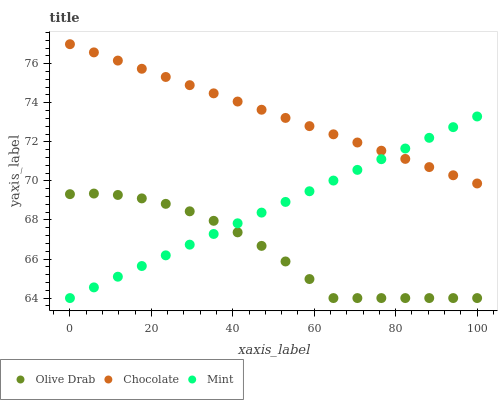Does Olive Drab have the minimum area under the curve?
Answer yes or no. Yes. Does Chocolate have the maximum area under the curve?
Answer yes or no. Yes. Does Chocolate have the minimum area under the curve?
Answer yes or no. No. Does Olive Drab have the maximum area under the curve?
Answer yes or no. No. Is Mint the smoothest?
Answer yes or no. Yes. Is Olive Drab the roughest?
Answer yes or no. Yes. Is Chocolate the smoothest?
Answer yes or no. No. Is Chocolate the roughest?
Answer yes or no. No. Does Mint have the lowest value?
Answer yes or no. Yes. Does Chocolate have the lowest value?
Answer yes or no. No. Does Chocolate have the highest value?
Answer yes or no. Yes. Does Olive Drab have the highest value?
Answer yes or no. No. Is Olive Drab less than Chocolate?
Answer yes or no. Yes. Is Chocolate greater than Olive Drab?
Answer yes or no. Yes. Does Olive Drab intersect Mint?
Answer yes or no. Yes. Is Olive Drab less than Mint?
Answer yes or no. No. Is Olive Drab greater than Mint?
Answer yes or no. No. Does Olive Drab intersect Chocolate?
Answer yes or no. No. 